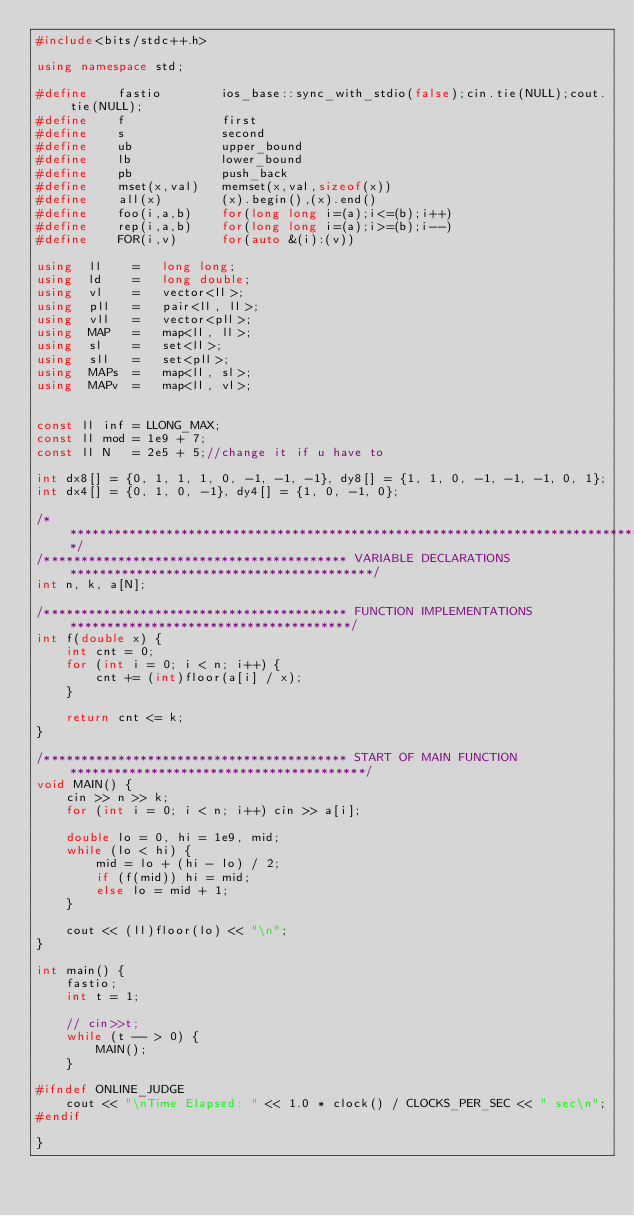Convert code to text. <code><loc_0><loc_0><loc_500><loc_500><_C++_>#include<bits/stdc++.h>

using namespace std;

#define    fastio        ios_base::sync_with_stdio(false);cin.tie(NULL);cout.tie(NULL);
#define    f             first
#define    s             second
#define    ub            upper_bound
#define    lb            lower_bound
#define    pb            push_back
#define    mset(x,val)   memset(x,val,sizeof(x))
#define    all(x)        (x).begin(),(x).end()
#define    foo(i,a,b)    for(long long i=(a);i<=(b);i++)
#define    rep(i,a,b)    for(long long i=(a);i>=(b);i--)
#define    FOR(i,v)      for(auto &(i):(v))

using  ll    =   long long;
using  ld    =   long double;
using  vl    =   vector<ll>;
using  pll   =   pair<ll, ll>;
using  vll   =   vector<pll>;
using  MAP   =   map<ll, ll>;
using  sl    =   set<ll>;
using  sll   =   set<pll>;
using  MAPs  =   map<ll, sl>;
using  MAPv  =   map<ll, vl>;


const ll inf = LLONG_MAX;
const ll mod = 1e9 + 7;
const ll N   = 2e5 + 5;//change it if u have to

int dx8[] = {0, 1, 1, 1, 0, -1, -1, -1}, dy8[] = {1, 1, 0, -1, -1, -1, 0, 1};
int dx4[] = {0, 1, 0, -1}, dy4[] = {1, 0, -1, 0};

/*********************************************************************************************************/
/***************************************** VARIABLE DECLARATIONS *****************************************/
int n, k, a[N];

/***************************************** FUNCTION IMPLEMENTATIONS **************************************/
int f(double x) {
    int cnt = 0;
    for (int i = 0; i < n; i++) {
        cnt += (int)floor(a[i] / x);
    }

    return cnt <= k;
}

/***************************************** START OF MAIN FUNCTION ****************************************/
void MAIN() {
    cin >> n >> k;
    for (int i = 0; i < n; i++) cin >> a[i];

    double lo = 0, hi = 1e9, mid;
    while (lo < hi) {
        mid = lo + (hi - lo) / 2;
        if (f(mid)) hi = mid;
        else lo = mid + 1;
    }

    cout << (ll)floor(lo) << "\n";
}

int main() {
    fastio;
    int t = 1;

    // cin>>t;
    while (t -- > 0) {
        MAIN();
    }

#ifndef ONLINE_JUDGE
    cout << "\nTime Elapsed: " << 1.0 * clock() / CLOCKS_PER_SEC << " sec\n";
#endif

}
</code> 